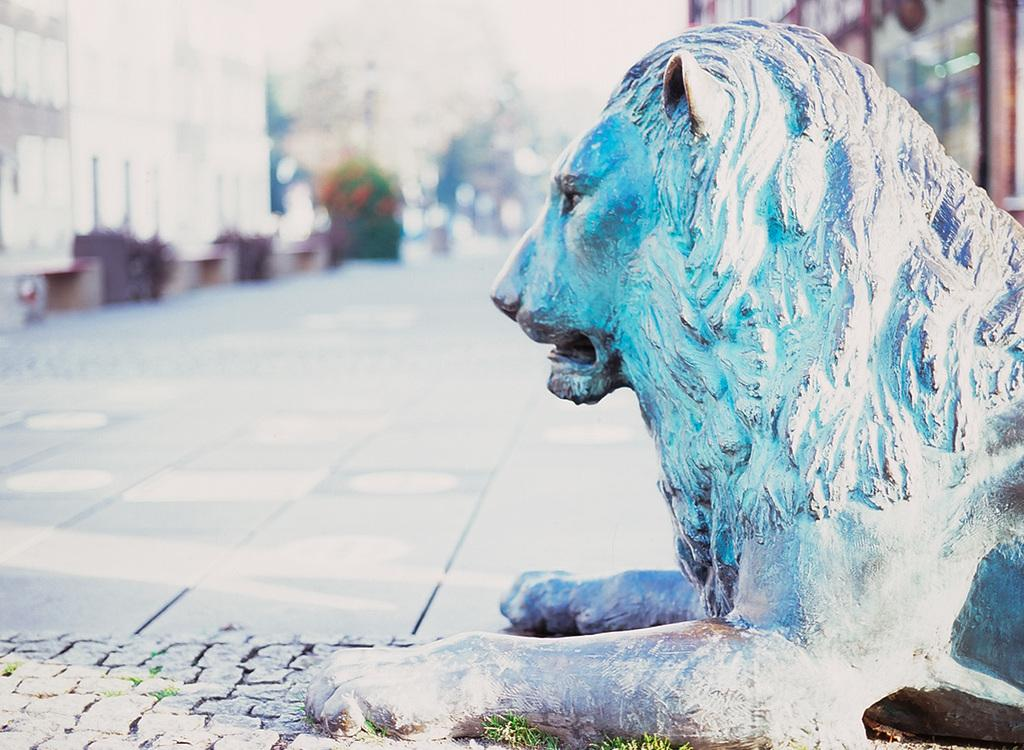What is the main subject of the image? There is a lion sculpture in the image. Where is the lion sculpture located? The lion sculpture is in front of a road. What other objects can be seen in the image? There are potted plants visible in the image. What type of structures are present in the image? There are buildings in the image. What type of skirt is the lion wearing in the image? There is no skirt present in the image, as the subject is a lion sculpture and not a living creature. 